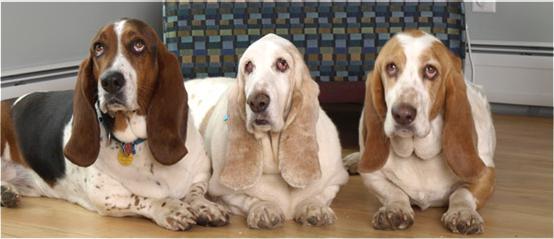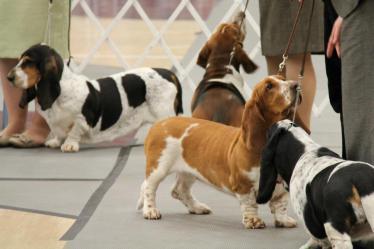The first image is the image on the left, the second image is the image on the right. Examine the images to the left and right. Is the description "At least one dog is resting on a couch." accurate? Answer yes or no. No. The first image is the image on the left, the second image is the image on the right. Evaluate the accuracy of this statement regarding the images: "Four long eared beagles are looking over a wooden barrier.". Is it true? Answer yes or no. No. 